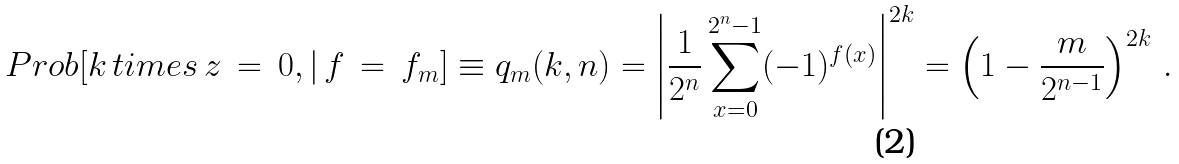<formula> <loc_0><loc_0><loc_500><loc_500>P r o b [ k \, t i m e s \, z \, = \, 0 , { | } \, f \, = \, f _ { m } ] \equiv q _ { m } ( k , n ) = \left | \frac { 1 } { 2 ^ { n } } \sum _ { x = 0 } ^ { 2 ^ { n } - 1 } ( - 1 ) ^ { f ( x ) } \right | ^ { 2 k } = \left ( 1 - \frac { m } { 2 ^ { n - 1 } } \right ) ^ { 2 k } \, .</formula> 